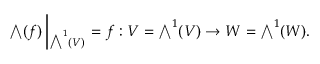<formula> <loc_0><loc_0><loc_500><loc_500>{ \bigwedge } ( f ) \left | _ { { \bigwedge } ^ { 1 } ( V ) } = f \colon V = { \bigwedge } ^ { 1 } ( V ) \rightarrow W = { \bigwedge } ^ { 1 } ( W ) .</formula> 